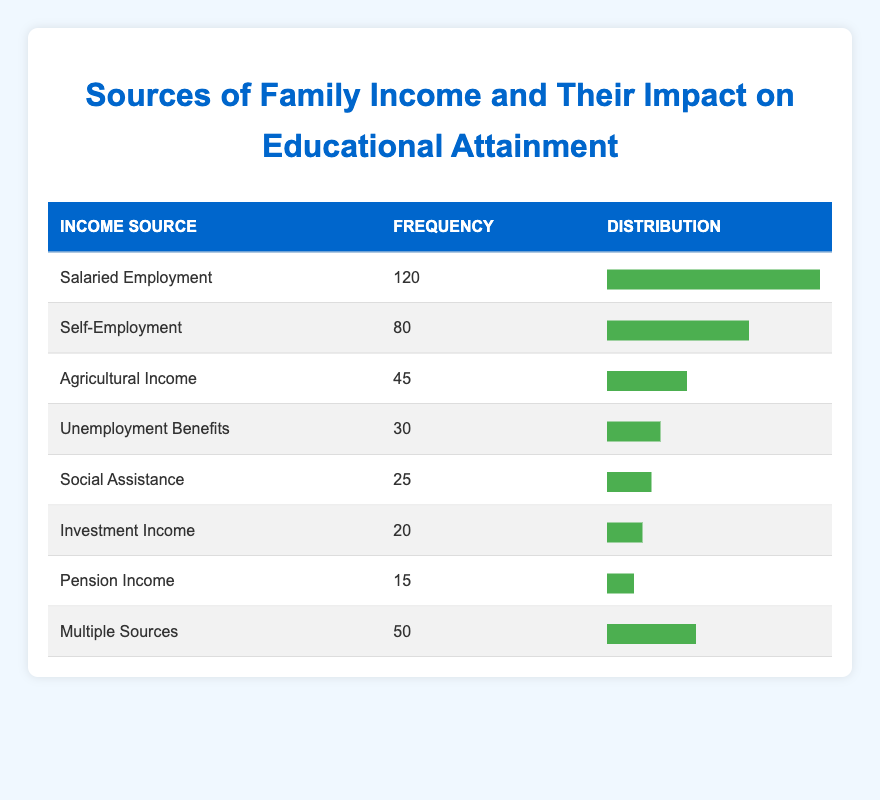What is the frequency for Salaried Employment? The frequency for Salaried Employment is directly stated in the table. It shows "Salaried Employment" with a frequency of 120.
Answer: 120 How many sources of family income are reported in the table? The table lists 8 different sources of family income. Each source is a separate entry in the table.
Answer: 8 What is the total frequency of income sources categorized as assistance (Unemployment Benefits and Social Assistance)? To find this total, we add the frequencies of "Unemployment Benefits" (30) and "Social Assistance" (25). So, 30 + 25 = 55.
Answer: 55 Which income source has the second highest frequency? The second highest frequency is for Self-Employment, which has a frequency of 80. Salaried Employment is the highest with 120.
Answer: Self-Employment Is Investment Income the least reported source of family income? By checking the frequencies, Investment Income has a frequency of 20, which is less than Pension Income (15), making it the least reported source.
Answer: No What percentage of families rely on Salaried Employment compared to those using Agricultural Income? To find the percentage, we calculate (Salaried Employment frequency 120 / Agricultural Income frequency 45) * 100 = (120/45)*100 = 266.67%. Therefore, families relying on Salaried Employment are more than twice as many as those relying on Agricultural Income.
Answer: 266.67% How many more families report a source of income from Self-Employment than from Pension Income? By checking the frequencies: Self-Employment has 80 and Pension Income has 15. Calculating the difference, 80 - 15 = 65.
Answer: 65 What is the average frequency of the income sources listed? The total frequency is calculated by summing all frequencies: 120 + 80 + 45 + 30 + 25 + 20 + 15 + 50 = 365. Then divide by the number of sources (8), so 365 / 8 = 45.625, which describes the average number of families per income source.
Answer: 45.625 How many income sources have a frequency of 50 or more? By reviewing the table, the sources with frequencies of 50 or more are Salaried Employment (120), Self-Employment (80), and Multiple Sources (50). This gives us a total of 3 sources.
Answer: 3 